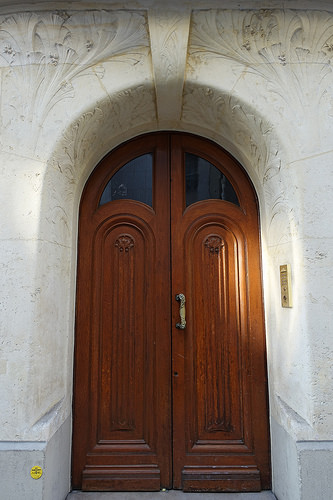<image>
Is the handle on the door? Yes. Looking at the image, I can see the handle is positioned on top of the door, with the door providing support. 